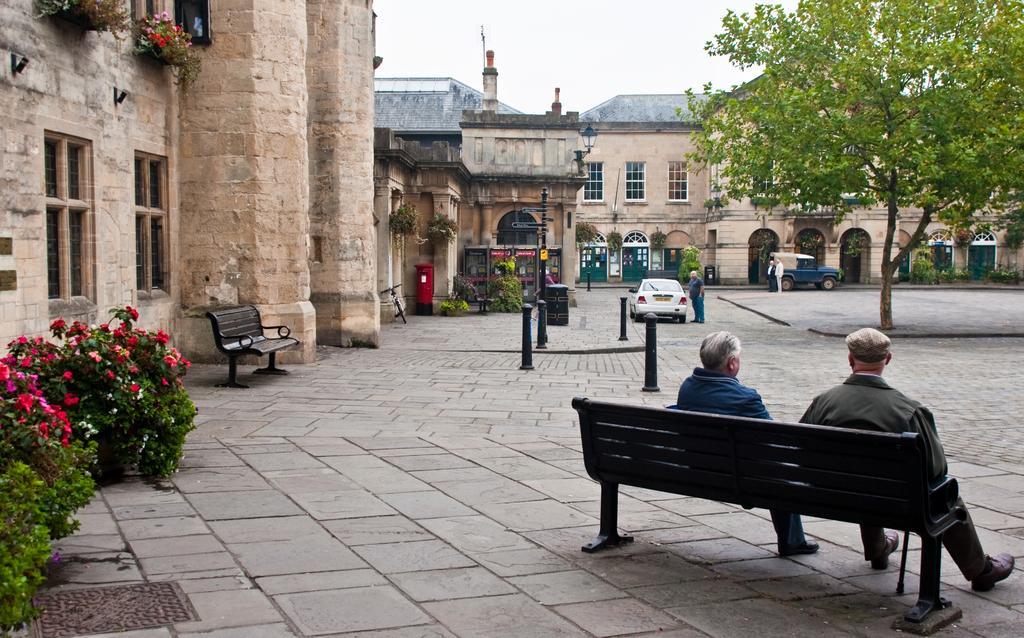How would you summarize this image in a sentence or two? These two persons are sitting on the bench. We can see plant,flowers,bench,buildings,tree,car. A for two persons are standing. 